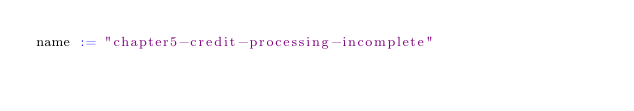<code> <loc_0><loc_0><loc_500><loc_500><_Scala_>name := "chapter5-credit-processing-incomplete"</code> 